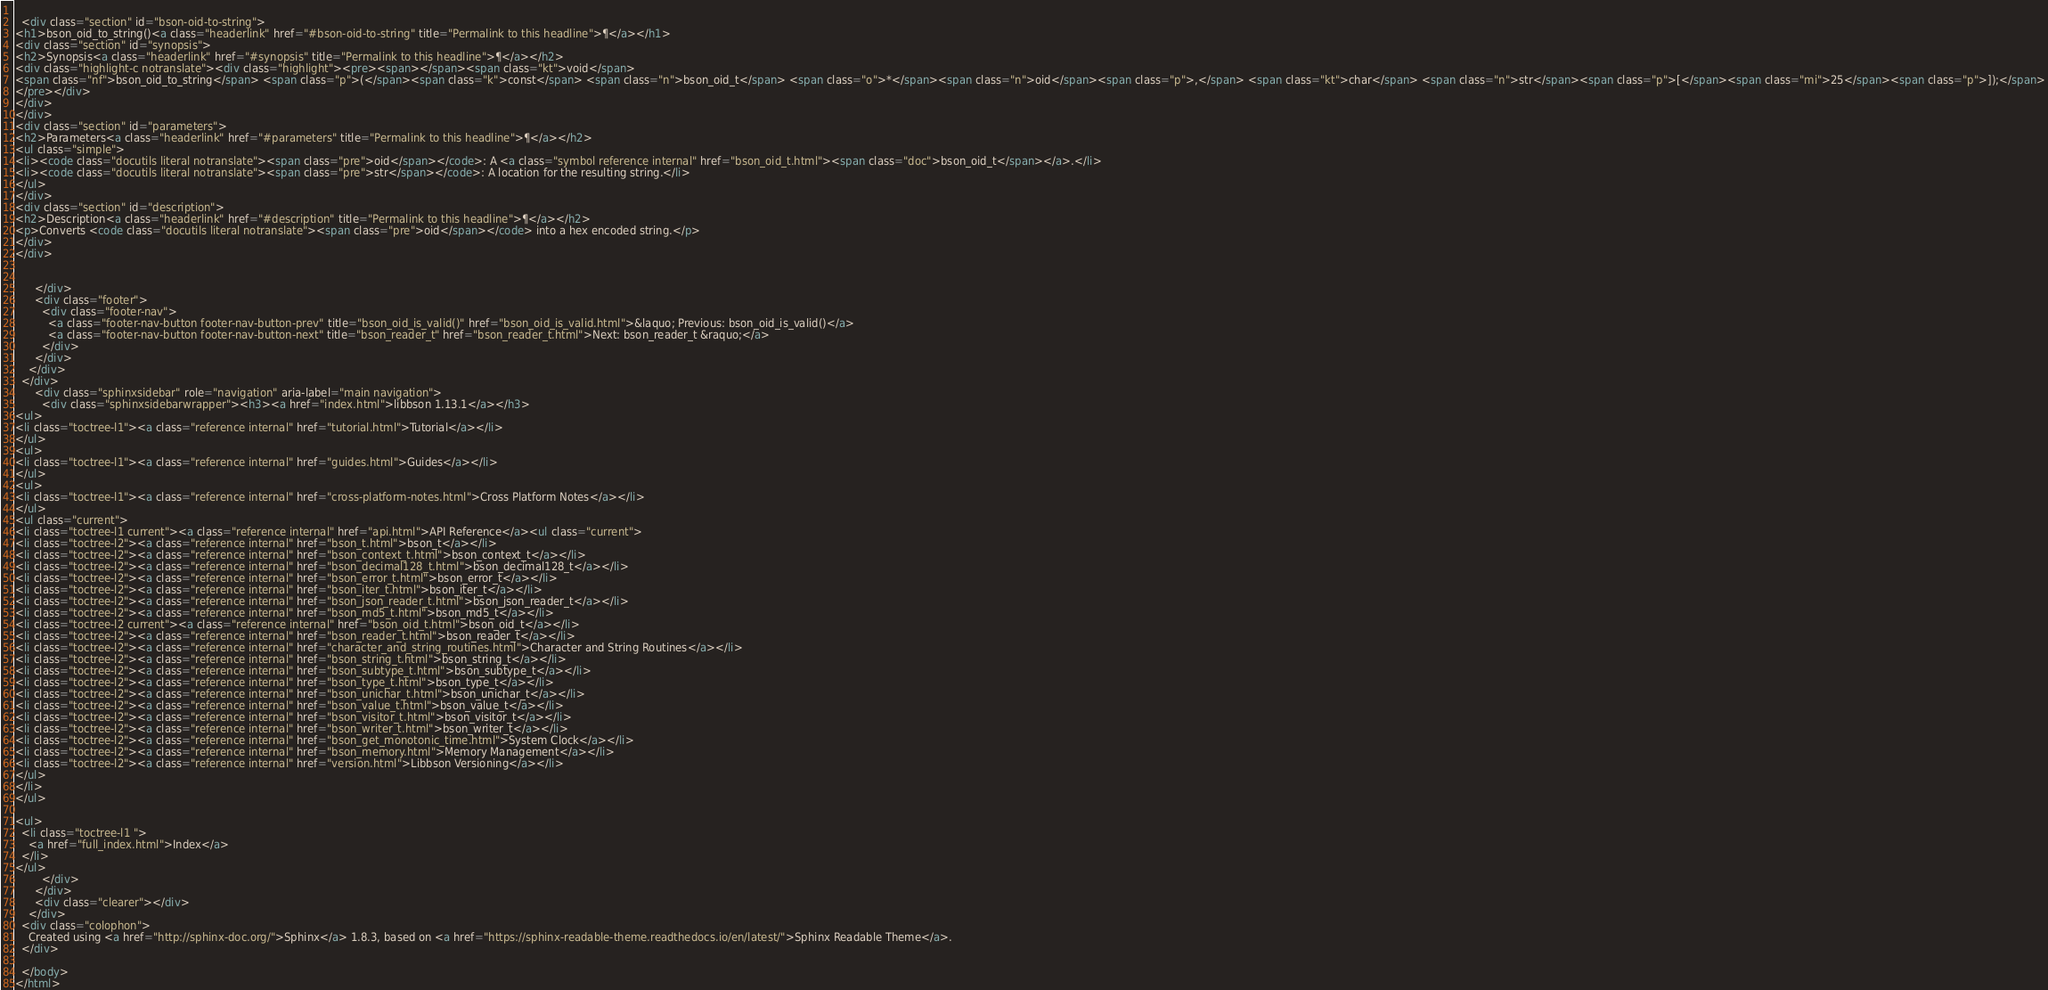Convert code to text. <code><loc_0><loc_0><loc_500><loc_500><_HTML_>        
  <div class="section" id="bson-oid-to-string">
<h1>bson_oid_to_string()<a class="headerlink" href="#bson-oid-to-string" title="Permalink to this headline">¶</a></h1>
<div class="section" id="synopsis">
<h2>Synopsis<a class="headerlink" href="#synopsis" title="Permalink to this headline">¶</a></h2>
<div class="highlight-c notranslate"><div class="highlight"><pre><span></span><span class="kt">void</span>
<span class="nf">bson_oid_to_string</span> <span class="p">(</span><span class="k">const</span> <span class="n">bson_oid_t</span> <span class="o">*</span><span class="n">oid</span><span class="p">,</span> <span class="kt">char</span> <span class="n">str</span><span class="p">[</span><span class="mi">25</span><span class="p">]);</span>
</pre></div>
</div>
</div>
<div class="section" id="parameters">
<h2>Parameters<a class="headerlink" href="#parameters" title="Permalink to this headline">¶</a></h2>
<ul class="simple">
<li><code class="docutils literal notranslate"><span class="pre">oid</span></code>: A <a class="symbol reference internal" href="bson_oid_t.html"><span class="doc">bson_oid_t</span></a>.</li>
<li><code class="docutils literal notranslate"><span class="pre">str</span></code>: A location for the resulting string.</li>
</ul>
</div>
<div class="section" id="description">
<h2>Description<a class="headerlink" href="#description" title="Permalink to this headline">¶</a></h2>
<p>Converts <code class="docutils literal notranslate"><span class="pre">oid</span></code> into a hex encoded string.</p>
</div>
</div>


      </div>
      <div class="footer">
        <div class="footer-nav">
          <a class="footer-nav-button footer-nav-button-prev" title="bson_oid_is_valid()" href="bson_oid_is_valid.html">&laquo; Previous: bson_oid_is_valid()</a>
          <a class="footer-nav-button footer-nav-button-next" title="bson_reader_t" href="bson_reader_t.html">Next: bson_reader_t &raquo;</a>
        </div>
      </div>
    </div>
  </div>
      <div class="sphinxsidebar" role="navigation" aria-label="main navigation">
        <div class="sphinxsidebarwrapper"><h3><a href="index.html">libbson 1.13.1</a></h3>
<ul>
<li class="toctree-l1"><a class="reference internal" href="tutorial.html">Tutorial</a></li>
</ul>
<ul>
<li class="toctree-l1"><a class="reference internal" href="guides.html">Guides</a></li>
</ul>
<ul>
<li class="toctree-l1"><a class="reference internal" href="cross-platform-notes.html">Cross Platform Notes</a></li>
</ul>
<ul class="current">
<li class="toctree-l1 current"><a class="reference internal" href="api.html">API Reference</a><ul class="current">
<li class="toctree-l2"><a class="reference internal" href="bson_t.html">bson_t</a></li>
<li class="toctree-l2"><a class="reference internal" href="bson_context_t.html">bson_context_t</a></li>
<li class="toctree-l2"><a class="reference internal" href="bson_decimal128_t.html">bson_decimal128_t</a></li>
<li class="toctree-l2"><a class="reference internal" href="bson_error_t.html">bson_error_t</a></li>
<li class="toctree-l2"><a class="reference internal" href="bson_iter_t.html">bson_iter_t</a></li>
<li class="toctree-l2"><a class="reference internal" href="bson_json_reader_t.html">bson_json_reader_t</a></li>
<li class="toctree-l2"><a class="reference internal" href="bson_md5_t.html">bson_md5_t</a></li>
<li class="toctree-l2 current"><a class="reference internal" href="bson_oid_t.html">bson_oid_t</a></li>
<li class="toctree-l2"><a class="reference internal" href="bson_reader_t.html">bson_reader_t</a></li>
<li class="toctree-l2"><a class="reference internal" href="character_and_string_routines.html">Character and String Routines</a></li>
<li class="toctree-l2"><a class="reference internal" href="bson_string_t.html">bson_string_t</a></li>
<li class="toctree-l2"><a class="reference internal" href="bson_subtype_t.html">bson_subtype_t</a></li>
<li class="toctree-l2"><a class="reference internal" href="bson_type_t.html">bson_type_t</a></li>
<li class="toctree-l2"><a class="reference internal" href="bson_unichar_t.html">bson_unichar_t</a></li>
<li class="toctree-l2"><a class="reference internal" href="bson_value_t.html">bson_value_t</a></li>
<li class="toctree-l2"><a class="reference internal" href="bson_visitor_t.html">bson_visitor_t</a></li>
<li class="toctree-l2"><a class="reference internal" href="bson_writer_t.html">bson_writer_t</a></li>
<li class="toctree-l2"><a class="reference internal" href="bson_get_monotonic_time.html">System Clock</a></li>
<li class="toctree-l2"><a class="reference internal" href="bson_memory.html">Memory Management</a></li>
<li class="toctree-l2"><a class="reference internal" href="version.html">Libbson Versioning</a></li>
</ul>
</li>
</ul>

<ul>
  <li class="toctree-l1 ">
    <a href="full_index.html">Index</a>
  </li>
</ul>
        </div>
      </div>
      <div class="clearer"></div>
    </div>
  <div class="colophon">
    Created using <a href="http://sphinx-doc.org/">Sphinx</a> 1.8.3, based on <a href="https://sphinx-readable-theme.readthedocs.io/en/latest/">Sphinx Readable Theme</a>.
  </div>

  </body>
</html></code> 